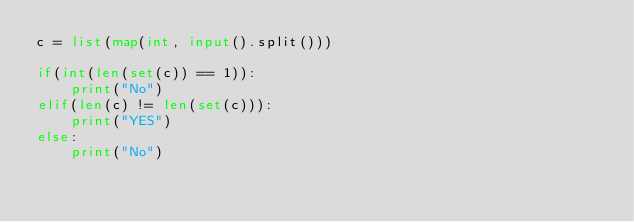Convert code to text. <code><loc_0><loc_0><loc_500><loc_500><_Python_>c = list(map(int, input().split()))

if(int(len(set(c)) == 1)):
    print("No")
elif(len(c) != len(set(c))):
    print("YES")
else:
    print("No")</code> 